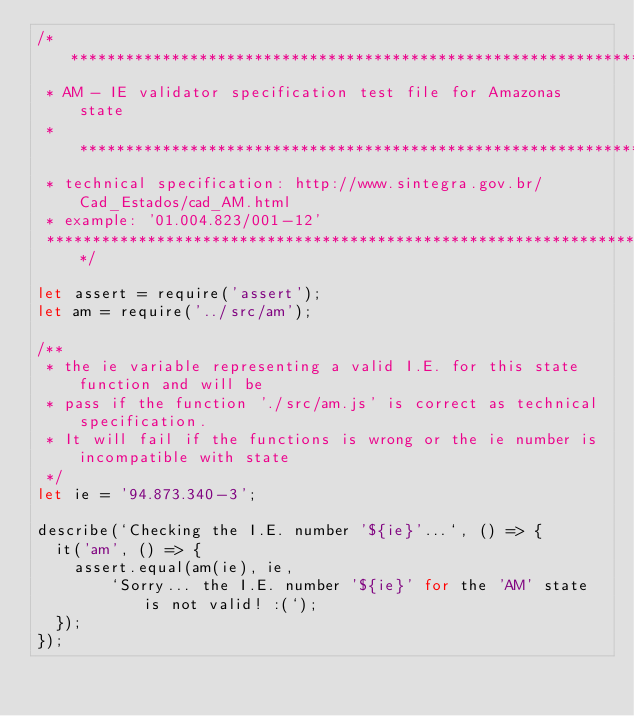<code> <loc_0><loc_0><loc_500><loc_500><_JavaScript_>/*******************************************************************************
 * AM - IE validator specification test file for Amazonas state
 * *****************************************************************************
 * technical specification: http://www.sintegra.gov.br/Cad_Estados/cad_AM.html
 * example: '01.004.823/001-12'
 ******************************************************************************/

let assert = require('assert');
let am = require('../src/am');

/**
 * the ie variable representing a valid I.E. for this state function and will be
 * pass if the function './src/am.js' is correct as technical specification.
 * It will fail if the functions is wrong or the ie number is incompatible with state
 */
let ie = '94.873.340-3';

describe(`Checking the I.E. number '${ie}'...`, () => {
  it('am', () => {
    assert.equal(am(ie), ie,
        `Sorry... the I.E. number '${ie}' for the 'AM' state is not valid! :(`);
  });
});</code> 